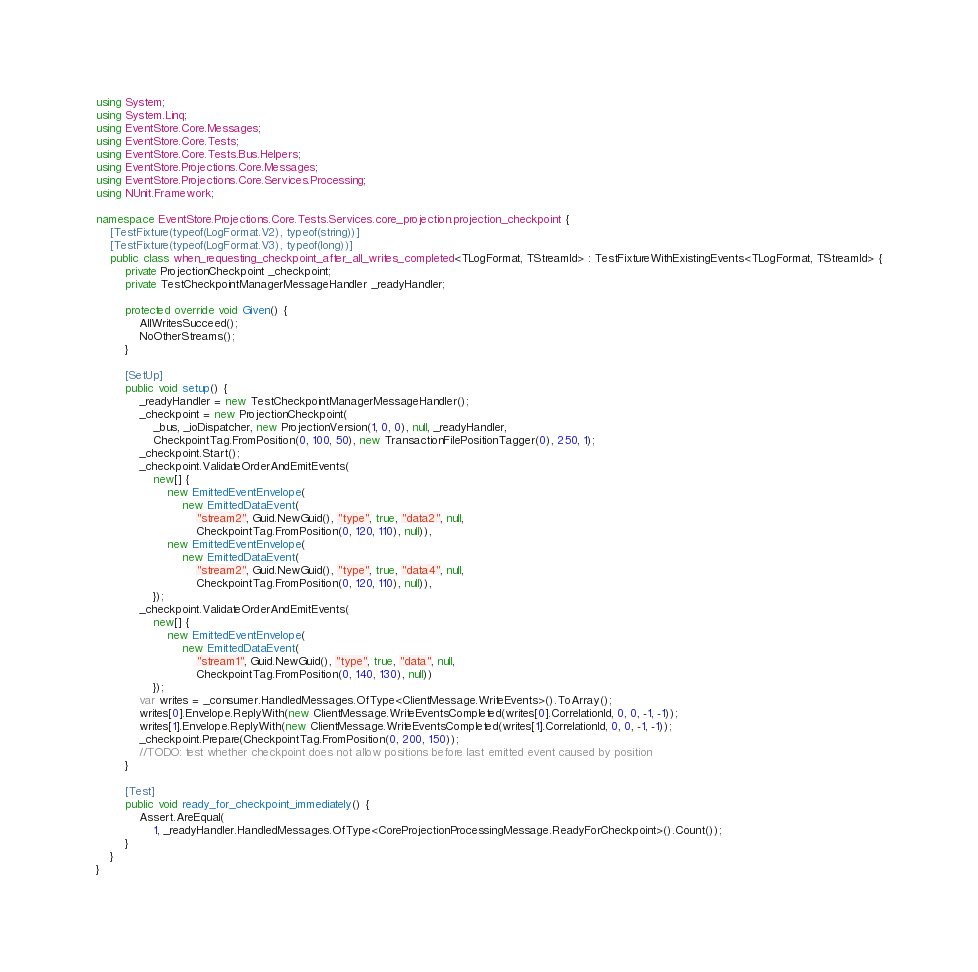<code> <loc_0><loc_0><loc_500><loc_500><_C#_>using System;
using System.Linq;
using EventStore.Core.Messages;
using EventStore.Core.Tests;
using EventStore.Core.Tests.Bus.Helpers;
using EventStore.Projections.Core.Messages;
using EventStore.Projections.Core.Services.Processing;
using NUnit.Framework;

namespace EventStore.Projections.Core.Tests.Services.core_projection.projection_checkpoint {
	[TestFixture(typeof(LogFormat.V2), typeof(string))]
	[TestFixture(typeof(LogFormat.V3), typeof(long))]
	public class when_requesting_checkpoint_after_all_writes_completed<TLogFormat, TStreamId> : TestFixtureWithExistingEvents<TLogFormat, TStreamId> {
		private ProjectionCheckpoint _checkpoint;
		private TestCheckpointManagerMessageHandler _readyHandler;

		protected override void Given() {
			AllWritesSucceed();
			NoOtherStreams();
		}

		[SetUp]
		public void setup() {
			_readyHandler = new TestCheckpointManagerMessageHandler();
			_checkpoint = new ProjectionCheckpoint(
				_bus, _ioDispatcher, new ProjectionVersion(1, 0, 0), null, _readyHandler,
				CheckpointTag.FromPosition(0, 100, 50), new TransactionFilePositionTagger(0), 250, 1);
			_checkpoint.Start();
			_checkpoint.ValidateOrderAndEmitEvents(
				new[] {
					new EmittedEventEnvelope(
						new EmittedDataEvent(
							"stream2", Guid.NewGuid(), "type", true, "data2", null,
							CheckpointTag.FromPosition(0, 120, 110), null)),
					new EmittedEventEnvelope(
						new EmittedDataEvent(
							"stream2", Guid.NewGuid(), "type", true, "data4", null,
							CheckpointTag.FromPosition(0, 120, 110), null)),
				});
			_checkpoint.ValidateOrderAndEmitEvents(
				new[] {
					new EmittedEventEnvelope(
						new EmittedDataEvent(
							"stream1", Guid.NewGuid(), "type", true, "data", null,
							CheckpointTag.FromPosition(0, 140, 130), null))
				});
			var writes = _consumer.HandledMessages.OfType<ClientMessage.WriteEvents>().ToArray();
			writes[0].Envelope.ReplyWith(new ClientMessage.WriteEventsCompleted(writes[0].CorrelationId, 0, 0, -1, -1));
			writes[1].Envelope.ReplyWith(new ClientMessage.WriteEventsCompleted(writes[1].CorrelationId, 0, 0, -1, -1));
			_checkpoint.Prepare(CheckpointTag.FromPosition(0, 200, 150));
			//TODO: test whether checkpoint does not allow positions before last emitted event caused by position
		}

		[Test]
		public void ready_for_checkpoint_immediately() {
			Assert.AreEqual(
				1, _readyHandler.HandledMessages.OfType<CoreProjectionProcessingMessage.ReadyForCheckpoint>().Count());
		}
	}
}
</code> 